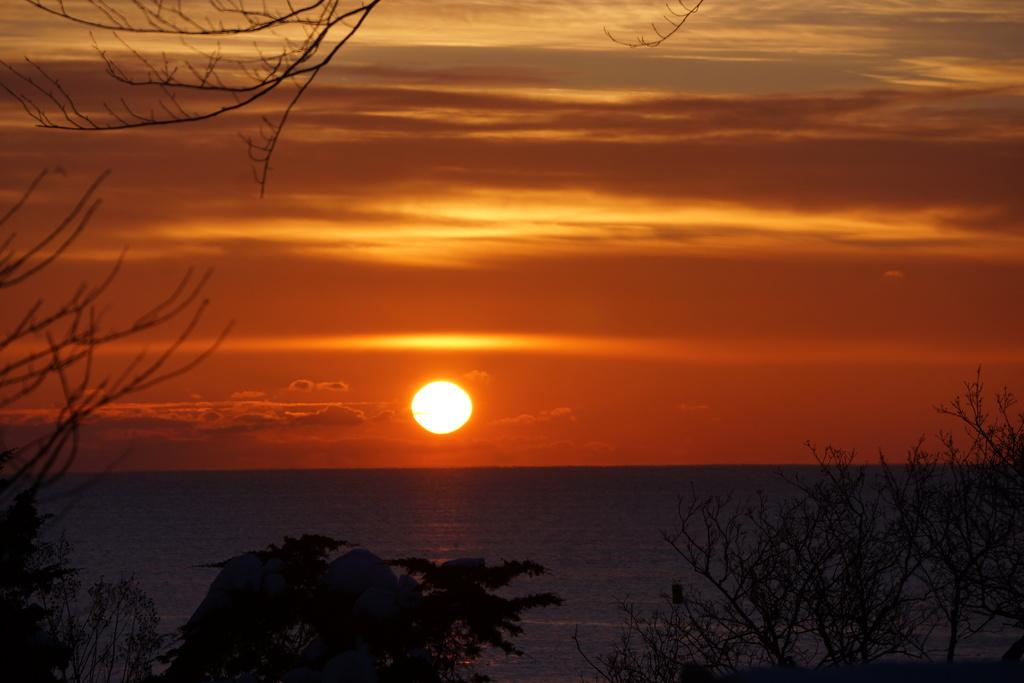What is happening in the sky in the image? There is a sunset in the image. What is the condition of the sky during the sunset? The sky is clear. What type of vegetation can be seen in the image? There are trees in the image. What natural feature is visible in the background of the image? There is an ocean in the image. What type of ring can be seen on the finger of the person in the image? There is no person present in the image, so it is not possible to determine if there is a ring on their finger. 